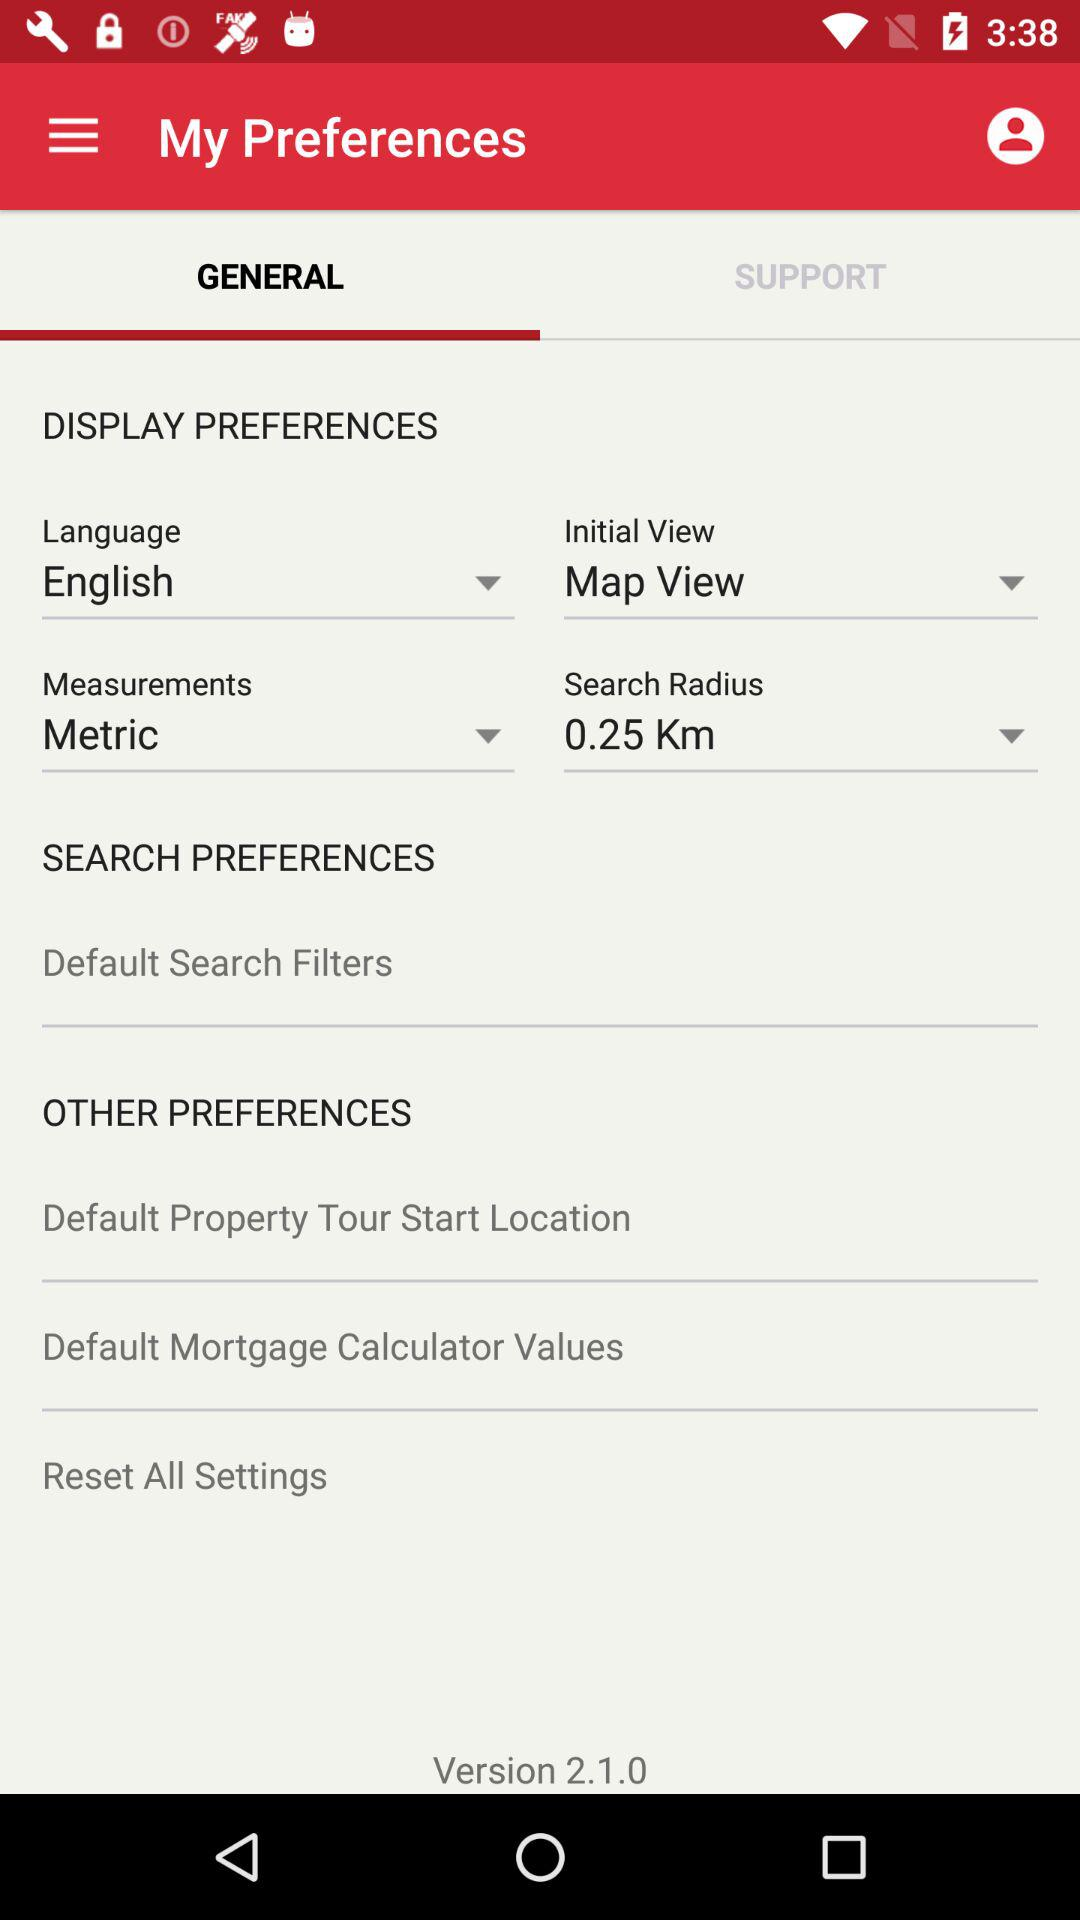What is the measurement system? The measurement system is metric. 